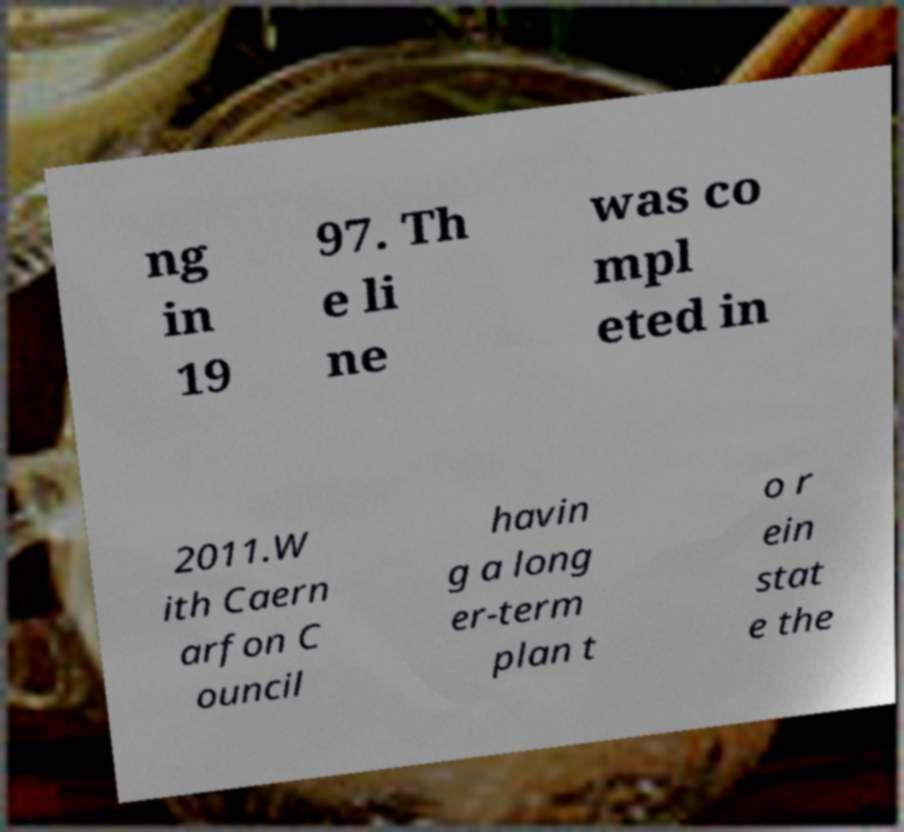Can you accurately transcribe the text from the provided image for me? ng in 19 97. Th e li ne was co mpl eted in 2011.W ith Caern arfon C ouncil havin g a long er-term plan t o r ein stat e the 